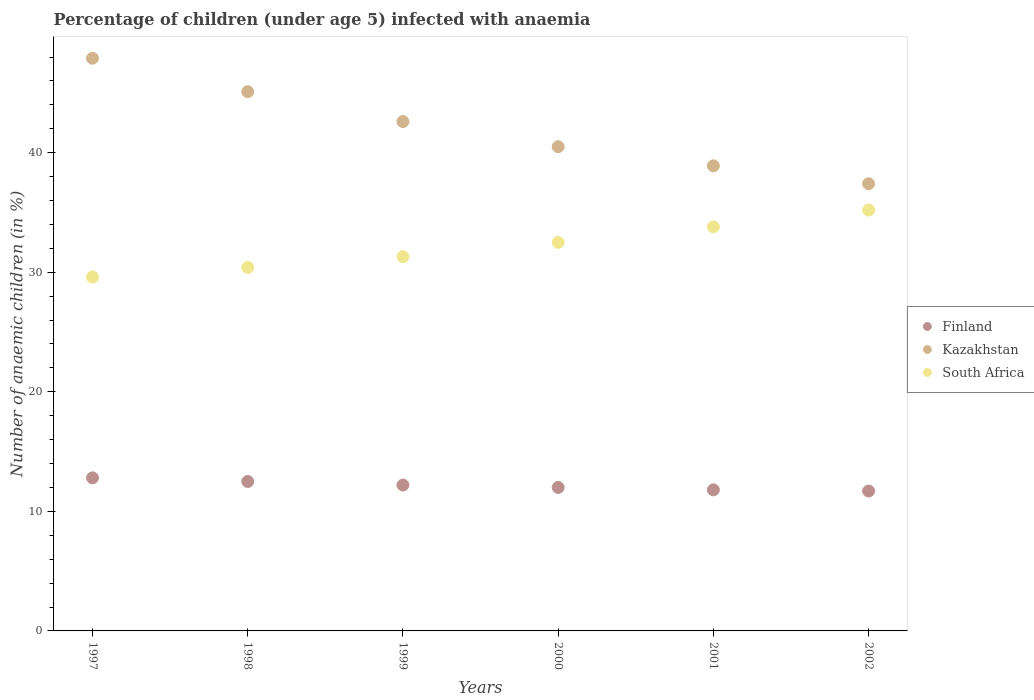How many different coloured dotlines are there?
Make the answer very short. 3. What is the percentage of children infected with anaemia in in Kazakhstan in 2000?
Provide a succinct answer. 40.5. Across all years, what is the minimum percentage of children infected with anaemia in in Finland?
Your response must be concise. 11.7. In which year was the percentage of children infected with anaemia in in Finland maximum?
Ensure brevity in your answer.  1997. What is the total percentage of children infected with anaemia in in South Africa in the graph?
Your response must be concise. 192.8. What is the difference between the percentage of children infected with anaemia in in Finland in 1997 and that in 1998?
Offer a very short reply. 0.3. What is the difference between the percentage of children infected with anaemia in in South Africa in 2002 and the percentage of children infected with anaemia in in Finland in 2000?
Offer a very short reply. 23.2. What is the average percentage of children infected with anaemia in in Kazakhstan per year?
Your answer should be compact. 42.07. What is the ratio of the percentage of children infected with anaemia in in South Africa in 2001 to that in 2002?
Offer a very short reply. 0.96. Is the percentage of children infected with anaemia in in South Africa in 1999 less than that in 2000?
Ensure brevity in your answer.  Yes. What is the difference between the highest and the second highest percentage of children infected with anaemia in in South Africa?
Offer a very short reply. 1.4. What is the difference between the highest and the lowest percentage of children infected with anaemia in in South Africa?
Offer a terse response. 5.6. Is it the case that in every year, the sum of the percentage of children infected with anaemia in in South Africa and percentage of children infected with anaemia in in Finland  is greater than the percentage of children infected with anaemia in in Kazakhstan?
Your answer should be compact. No. How many dotlines are there?
Provide a succinct answer. 3. How many years are there in the graph?
Keep it short and to the point. 6. What is the difference between two consecutive major ticks on the Y-axis?
Offer a terse response. 10. Are the values on the major ticks of Y-axis written in scientific E-notation?
Ensure brevity in your answer.  No. Does the graph contain any zero values?
Offer a terse response. No. Does the graph contain grids?
Your response must be concise. No. Where does the legend appear in the graph?
Offer a very short reply. Center right. How many legend labels are there?
Your response must be concise. 3. How are the legend labels stacked?
Ensure brevity in your answer.  Vertical. What is the title of the graph?
Your response must be concise. Percentage of children (under age 5) infected with anaemia. Does "Afghanistan" appear as one of the legend labels in the graph?
Offer a very short reply. No. What is the label or title of the X-axis?
Offer a very short reply. Years. What is the label or title of the Y-axis?
Make the answer very short. Number of anaemic children (in %). What is the Number of anaemic children (in %) of Kazakhstan in 1997?
Your answer should be compact. 47.9. What is the Number of anaemic children (in %) in South Africa in 1997?
Provide a succinct answer. 29.6. What is the Number of anaemic children (in %) in Kazakhstan in 1998?
Your response must be concise. 45.1. What is the Number of anaemic children (in %) in South Africa in 1998?
Your answer should be very brief. 30.4. What is the Number of anaemic children (in %) of Kazakhstan in 1999?
Your answer should be compact. 42.6. What is the Number of anaemic children (in %) of South Africa in 1999?
Ensure brevity in your answer.  31.3. What is the Number of anaemic children (in %) of Kazakhstan in 2000?
Your answer should be compact. 40.5. What is the Number of anaemic children (in %) of South Africa in 2000?
Give a very brief answer. 32.5. What is the Number of anaemic children (in %) of Finland in 2001?
Offer a terse response. 11.8. What is the Number of anaemic children (in %) of Kazakhstan in 2001?
Give a very brief answer. 38.9. What is the Number of anaemic children (in %) of South Africa in 2001?
Make the answer very short. 33.8. What is the Number of anaemic children (in %) in Kazakhstan in 2002?
Your response must be concise. 37.4. What is the Number of anaemic children (in %) in South Africa in 2002?
Provide a succinct answer. 35.2. Across all years, what is the maximum Number of anaemic children (in %) in Finland?
Your answer should be compact. 12.8. Across all years, what is the maximum Number of anaemic children (in %) in Kazakhstan?
Give a very brief answer. 47.9. Across all years, what is the maximum Number of anaemic children (in %) in South Africa?
Ensure brevity in your answer.  35.2. Across all years, what is the minimum Number of anaemic children (in %) in Kazakhstan?
Your response must be concise. 37.4. Across all years, what is the minimum Number of anaemic children (in %) in South Africa?
Ensure brevity in your answer.  29.6. What is the total Number of anaemic children (in %) in Finland in the graph?
Offer a very short reply. 73. What is the total Number of anaemic children (in %) in Kazakhstan in the graph?
Offer a very short reply. 252.4. What is the total Number of anaemic children (in %) of South Africa in the graph?
Your answer should be very brief. 192.8. What is the difference between the Number of anaemic children (in %) of South Africa in 1997 and that in 1998?
Your answer should be compact. -0.8. What is the difference between the Number of anaemic children (in %) of Kazakhstan in 1997 and that in 1999?
Make the answer very short. 5.3. What is the difference between the Number of anaemic children (in %) in Finland in 1997 and that in 2000?
Keep it short and to the point. 0.8. What is the difference between the Number of anaemic children (in %) in Kazakhstan in 1997 and that in 2001?
Make the answer very short. 9. What is the difference between the Number of anaemic children (in %) in South Africa in 1997 and that in 2001?
Keep it short and to the point. -4.2. What is the difference between the Number of anaemic children (in %) of Kazakhstan in 1997 and that in 2002?
Make the answer very short. 10.5. What is the difference between the Number of anaemic children (in %) of South Africa in 1997 and that in 2002?
Offer a terse response. -5.6. What is the difference between the Number of anaemic children (in %) of South Africa in 1998 and that in 1999?
Your response must be concise. -0.9. What is the difference between the Number of anaemic children (in %) of Finland in 1998 and that in 2000?
Keep it short and to the point. 0.5. What is the difference between the Number of anaemic children (in %) of Finland in 1998 and that in 2001?
Your response must be concise. 0.7. What is the difference between the Number of anaemic children (in %) of Kazakhstan in 1998 and that in 2001?
Make the answer very short. 6.2. What is the difference between the Number of anaemic children (in %) of Finland in 1998 and that in 2002?
Provide a short and direct response. 0.8. What is the difference between the Number of anaemic children (in %) in Kazakhstan in 1998 and that in 2002?
Keep it short and to the point. 7.7. What is the difference between the Number of anaemic children (in %) of Finland in 1999 and that in 2001?
Make the answer very short. 0.4. What is the difference between the Number of anaemic children (in %) in Kazakhstan in 1999 and that in 2001?
Offer a very short reply. 3.7. What is the difference between the Number of anaemic children (in %) in Kazakhstan in 1999 and that in 2002?
Your answer should be compact. 5.2. What is the difference between the Number of anaemic children (in %) in Kazakhstan in 2000 and that in 2001?
Offer a terse response. 1.6. What is the difference between the Number of anaemic children (in %) in Kazakhstan in 2000 and that in 2002?
Provide a succinct answer. 3.1. What is the difference between the Number of anaemic children (in %) of Finland in 2001 and that in 2002?
Provide a short and direct response. 0.1. What is the difference between the Number of anaemic children (in %) in South Africa in 2001 and that in 2002?
Ensure brevity in your answer.  -1.4. What is the difference between the Number of anaemic children (in %) of Finland in 1997 and the Number of anaemic children (in %) of Kazakhstan in 1998?
Ensure brevity in your answer.  -32.3. What is the difference between the Number of anaemic children (in %) of Finland in 1997 and the Number of anaemic children (in %) of South Africa in 1998?
Provide a short and direct response. -17.6. What is the difference between the Number of anaemic children (in %) in Finland in 1997 and the Number of anaemic children (in %) in Kazakhstan in 1999?
Make the answer very short. -29.8. What is the difference between the Number of anaemic children (in %) in Finland in 1997 and the Number of anaemic children (in %) in South Africa in 1999?
Your answer should be compact. -18.5. What is the difference between the Number of anaemic children (in %) of Finland in 1997 and the Number of anaemic children (in %) of Kazakhstan in 2000?
Your answer should be very brief. -27.7. What is the difference between the Number of anaemic children (in %) of Finland in 1997 and the Number of anaemic children (in %) of South Africa in 2000?
Ensure brevity in your answer.  -19.7. What is the difference between the Number of anaemic children (in %) in Kazakhstan in 1997 and the Number of anaemic children (in %) in South Africa in 2000?
Offer a terse response. 15.4. What is the difference between the Number of anaemic children (in %) in Finland in 1997 and the Number of anaemic children (in %) in Kazakhstan in 2001?
Offer a terse response. -26.1. What is the difference between the Number of anaemic children (in %) in Kazakhstan in 1997 and the Number of anaemic children (in %) in South Africa in 2001?
Give a very brief answer. 14.1. What is the difference between the Number of anaemic children (in %) in Finland in 1997 and the Number of anaemic children (in %) in Kazakhstan in 2002?
Offer a terse response. -24.6. What is the difference between the Number of anaemic children (in %) of Finland in 1997 and the Number of anaemic children (in %) of South Africa in 2002?
Give a very brief answer. -22.4. What is the difference between the Number of anaemic children (in %) of Kazakhstan in 1997 and the Number of anaemic children (in %) of South Africa in 2002?
Make the answer very short. 12.7. What is the difference between the Number of anaemic children (in %) in Finland in 1998 and the Number of anaemic children (in %) in Kazakhstan in 1999?
Make the answer very short. -30.1. What is the difference between the Number of anaemic children (in %) in Finland in 1998 and the Number of anaemic children (in %) in South Africa in 1999?
Provide a short and direct response. -18.8. What is the difference between the Number of anaemic children (in %) in Finland in 1998 and the Number of anaemic children (in %) in Kazakhstan in 2001?
Make the answer very short. -26.4. What is the difference between the Number of anaemic children (in %) in Finland in 1998 and the Number of anaemic children (in %) in South Africa in 2001?
Keep it short and to the point. -21.3. What is the difference between the Number of anaemic children (in %) in Kazakhstan in 1998 and the Number of anaemic children (in %) in South Africa in 2001?
Make the answer very short. 11.3. What is the difference between the Number of anaemic children (in %) of Finland in 1998 and the Number of anaemic children (in %) of Kazakhstan in 2002?
Provide a short and direct response. -24.9. What is the difference between the Number of anaemic children (in %) of Finland in 1998 and the Number of anaemic children (in %) of South Africa in 2002?
Provide a short and direct response. -22.7. What is the difference between the Number of anaemic children (in %) of Kazakhstan in 1998 and the Number of anaemic children (in %) of South Africa in 2002?
Provide a short and direct response. 9.9. What is the difference between the Number of anaemic children (in %) in Finland in 1999 and the Number of anaemic children (in %) in Kazakhstan in 2000?
Your answer should be very brief. -28.3. What is the difference between the Number of anaemic children (in %) of Finland in 1999 and the Number of anaemic children (in %) of South Africa in 2000?
Make the answer very short. -20.3. What is the difference between the Number of anaemic children (in %) of Finland in 1999 and the Number of anaemic children (in %) of Kazakhstan in 2001?
Offer a very short reply. -26.7. What is the difference between the Number of anaemic children (in %) in Finland in 1999 and the Number of anaemic children (in %) in South Africa in 2001?
Your answer should be compact. -21.6. What is the difference between the Number of anaemic children (in %) of Finland in 1999 and the Number of anaemic children (in %) of Kazakhstan in 2002?
Your response must be concise. -25.2. What is the difference between the Number of anaemic children (in %) in Kazakhstan in 1999 and the Number of anaemic children (in %) in South Africa in 2002?
Provide a short and direct response. 7.4. What is the difference between the Number of anaemic children (in %) in Finland in 2000 and the Number of anaemic children (in %) in Kazakhstan in 2001?
Offer a very short reply. -26.9. What is the difference between the Number of anaemic children (in %) in Finland in 2000 and the Number of anaemic children (in %) in South Africa in 2001?
Your response must be concise. -21.8. What is the difference between the Number of anaemic children (in %) in Kazakhstan in 2000 and the Number of anaemic children (in %) in South Africa in 2001?
Provide a succinct answer. 6.7. What is the difference between the Number of anaemic children (in %) of Finland in 2000 and the Number of anaemic children (in %) of Kazakhstan in 2002?
Your answer should be compact. -25.4. What is the difference between the Number of anaemic children (in %) of Finland in 2000 and the Number of anaemic children (in %) of South Africa in 2002?
Offer a terse response. -23.2. What is the difference between the Number of anaemic children (in %) in Kazakhstan in 2000 and the Number of anaemic children (in %) in South Africa in 2002?
Keep it short and to the point. 5.3. What is the difference between the Number of anaemic children (in %) in Finland in 2001 and the Number of anaemic children (in %) in Kazakhstan in 2002?
Make the answer very short. -25.6. What is the difference between the Number of anaemic children (in %) of Finland in 2001 and the Number of anaemic children (in %) of South Africa in 2002?
Offer a very short reply. -23.4. What is the average Number of anaemic children (in %) of Finland per year?
Keep it short and to the point. 12.17. What is the average Number of anaemic children (in %) in Kazakhstan per year?
Offer a very short reply. 42.07. What is the average Number of anaemic children (in %) in South Africa per year?
Offer a terse response. 32.13. In the year 1997, what is the difference between the Number of anaemic children (in %) of Finland and Number of anaemic children (in %) of Kazakhstan?
Give a very brief answer. -35.1. In the year 1997, what is the difference between the Number of anaemic children (in %) in Finland and Number of anaemic children (in %) in South Africa?
Keep it short and to the point. -16.8. In the year 1997, what is the difference between the Number of anaemic children (in %) of Kazakhstan and Number of anaemic children (in %) of South Africa?
Make the answer very short. 18.3. In the year 1998, what is the difference between the Number of anaemic children (in %) of Finland and Number of anaemic children (in %) of Kazakhstan?
Give a very brief answer. -32.6. In the year 1998, what is the difference between the Number of anaemic children (in %) in Finland and Number of anaemic children (in %) in South Africa?
Keep it short and to the point. -17.9. In the year 1999, what is the difference between the Number of anaemic children (in %) in Finland and Number of anaemic children (in %) in Kazakhstan?
Keep it short and to the point. -30.4. In the year 1999, what is the difference between the Number of anaemic children (in %) of Finland and Number of anaemic children (in %) of South Africa?
Keep it short and to the point. -19.1. In the year 2000, what is the difference between the Number of anaemic children (in %) of Finland and Number of anaemic children (in %) of Kazakhstan?
Offer a very short reply. -28.5. In the year 2000, what is the difference between the Number of anaemic children (in %) of Finland and Number of anaemic children (in %) of South Africa?
Your response must be concise. -20.5. In the year 2001, what is the difference between the Number of anaemic children (in %) in Finland and Number of anaemic children (in %) in Kazakhstan?
Give a very brief answer. -27.1. In the year 2002, what is the difference between the Number of anaemic children (in %) of Finland and Number of anaemic children (in %) of Kazakhstan?
Offer a terse response. -25.7. In the year 2002, what is the difference between the Number of anaemic children (in %) of Finland and Number of anaemic children (in %) of South Africa?
Your answer should be compact. -23.5. In the year 2002, what is the difference between the Number of anaemic children (in %) of Kazakhstan and Number of anaemic children (in %) of South Africa?
Your answer should be compact. 2.2. What is the ratio of the Number of anaemic children (in %) in Kazakhstan in 1997 to that in 1998?
Ensure brevity in your answer.  1.06. What is the ratio of the Number of anaemic children (in %) of South Africa in 1997 to that in 1998?
Provide a short and direct response. 0.97. What is the ratio of the Number of anaemic children (in %) in Finland in 1997 to that in 1999?
Keep it short and to the point. 1.05. What is the ratio of the Number of anaemic children (in %) in Kazakhstan in 1997 to that in 1999?
Provide a short and direct response. 1.12. What is the ratio of the Number of anaemic children (in %) of South Africa in 1997 to that in 1999?
Your answer should be very brief. 0.95. What is the ratio of the Number of anaemic children (in %) of Finland in 1997 to that in 2000?
Make the answer very short. 1.07. What is the ratio of the Number of anaemic children (in %) in Kazakhstan in 1997 to that in 2000?
Your answer should be compact. 1.18. What is the ratio of the Number of anaemic children (in %) in South Africa in 1997 to that in 2000?
Give a very brief answer. 0.91. What is the ratio of the Number of anaemic children (in %) of Finland in 1997 to that in 2001?
Provide a short and direct response. 1.08. What is the ratio of the Number of anaemic children (in %) in Kazakhstan in 1997 to that in 2001?
Ensure brevity in your answer.  1.23. What is the ratio of the Number of anaemic children (in %) of South Africa in 1997 to that in 2001?
Your response must be concise. 0.88. What is the ratio of the Number of anaemic children (in %) of Finland in 1997 to that in 2002?
Provide a short and direct response. 1.09. What is the ratio of the Number of anaemic children (in %) of Kazakhstan in 1997 to that in 2002?
Your answer should be compact. 1.28. What is the ratio of the Number of anaemic children (in %) in South Africa in 1997 to that in 2002?
Keep it short and to the point. 0.84. What is the ratio of the Number of anaemic children (in %) of Finland in 1998 to that in 1999?
Give a very brief answer. 1.02. What is the ratio of the Number of anaemic children (in %) of Kazakhstan in 1998 to that in 1999?
Your answer should be very brief. 1.06. What is the ratio of the Number of anaemic children (in %) in South Africa in 1998 to that in 1999?
Offer a very short reply. 0.97. What is the ratio of the Number of anaemic children (in %) in Finland in 1998 to that in 2000?
Keep it short and to the point. 1.04. What is the ratio of the Number of anaemic children (in %) in Kazakhstan in 1998 to that in 2000?
Provide a short and direct response. 1.11. What is the ratio of the Number of anaemic children (in %) in South Africa in 1998 to that in 2000?
Make the answer very short. 0.94. What is the ratio of the Number of anaemic children (in %) of Finland in 1998 to that in 2001?
Ensure brevity in your answer.  1.06. What is the ratio of the Number of anaemic children (in %) of Kazakhstan in 1998 to that in 2001?
Make the answer very short. 1.16. What is the ratio of the Number of anaemic children (in %) in South Africa in 1998 to that in 2001?
Your response must be concise. 0.9. What is the ratio of the Number of anaemic children (in %) of Finland in 1998 to that in 2002?
Provide a succinct answer. 1.07. What is the ratio of the Number of anaemic children (in %) in Kazakhstan in 1998 to that in 2002?
Ensure brevity in your answer.  1.21. What is the ratio of the Number of anaemic children (in %) in South Africa in 1998 to that in 2002?
Ensure brevity in your answer.  0.86. What is the ratio of the Number of anaemic children (in %) of Finland in 1999 to that in 2000?
Offer a terse response. 1.02. What is the ratio of the Number of anaemic children (in %) of Kazakhstan in 1999 to that in 2000?
Ensure brevity in your answer.  1.05. What is the ratio of the Number of anaemic children (in %) in South Africa in 1999 to that in 2000?
Keep it short and to the point. 0.96. What is the ratio of the Number of anaemic children (in %) of Finland in 1999 to that in 2001?
Your answer should be very brief. 1.03. What is the ratio of the Number of anaemic children (in %) in Kazakhstan in 1999 to that in 2001?
Offer a very short reply. 1.1. What is the ratio of the Number of anaemic children (in %) in South Africa in 1999 to that in 2001?
Your response must be concise. 0.93. What is the ratio of the Number of anaemic children (in %) of Finland in 1999 to that in 2002?
Offer a terse response. 1.04. What is the ratio of the Number of anaemic children (in %) of Kazakhstan in 1999 to that in 2002?
Your answer should be compact. 1.14. What is the ratio of the Number of anaemic children (in %) of South Africa in 1999 to that in 2002?
Provide a succinct answer. 0.89. What is the ratio of the Number of anaemic children (in %) in Finland in 2000 to that in 2001?
Your answer should be compact. 1.02. What is the ratio of the Number of anaemic children (in %) of Kazakhstan in 2000 to that in 2001?
Make the answer very short. 1.04. What is the ratio of the Number of anaemic children (in %) in South Africa in 2000 to that in 2001?
Provide a short and direct response. 0.96. What is the ratio of the Number of anaemic children (in %) in Finland in 2000 to that in 2002?
Provide a short and direct response. 1.03. What is the ratio of the Number of anaemic children (in %) of Kazakhstan in 2000 to that in 2002?
Your answer should be compact. 1.08. What is the ratio of the Number of anaemic children (in %) in South Africa in 2000 to that in 2002?
Your answer should be compact. 0.92. What is the ratio of the Number of anaemic children (in %) of Finland in 2001 to that in 2002?
Offer a terse response. 1.01. What is the ratio of the Number of anaemic children (in %) of Kazakhstan in 2001 to that in 2002?
Your response must be concise. 1.04. What is the ratio of the Number of anaemic children (in %) of South Africa in 2001 to that in 2002?
Provide a succinct answer. 0.96. What is the difference between the highest and the second highest Number of anaemic children (in %) in Finland?
Keep it short and to the point. 0.3. What is the difference between the highest and the second highest Number of anaemic children (in %) in Kazakhstan?
Ensure brevity in your answer.  2.8. What is the difference between the highest and the second highest Number of anaemic children (in %) in South Africa?
Offer a very short reply. 1.4. What is the difference between the highest and the lowest Number of anaemic children (in %) in South Africa?
Give a very brief answer. 5.6. 